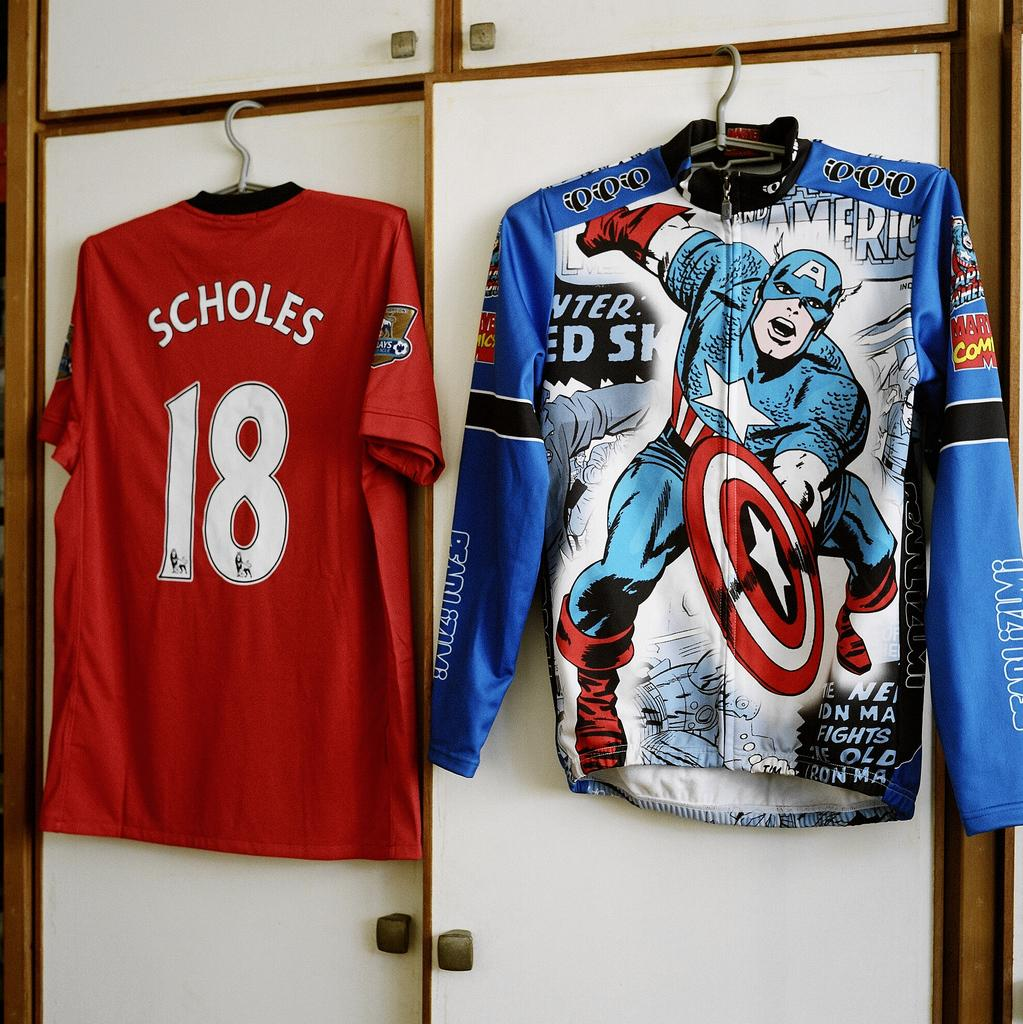<image>
Describe the image concisely. A blue zip up Captain American jacket with fight written on it. 